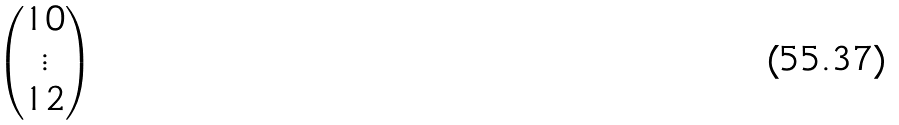Convert formula to latex. <formula><loc_0><loc_0><loc_500><loc_500>\begin{pmatrix} { 1 0 } \\ \vdots \\ { 1 { 2 } } \end{pmatrix}</formula> 